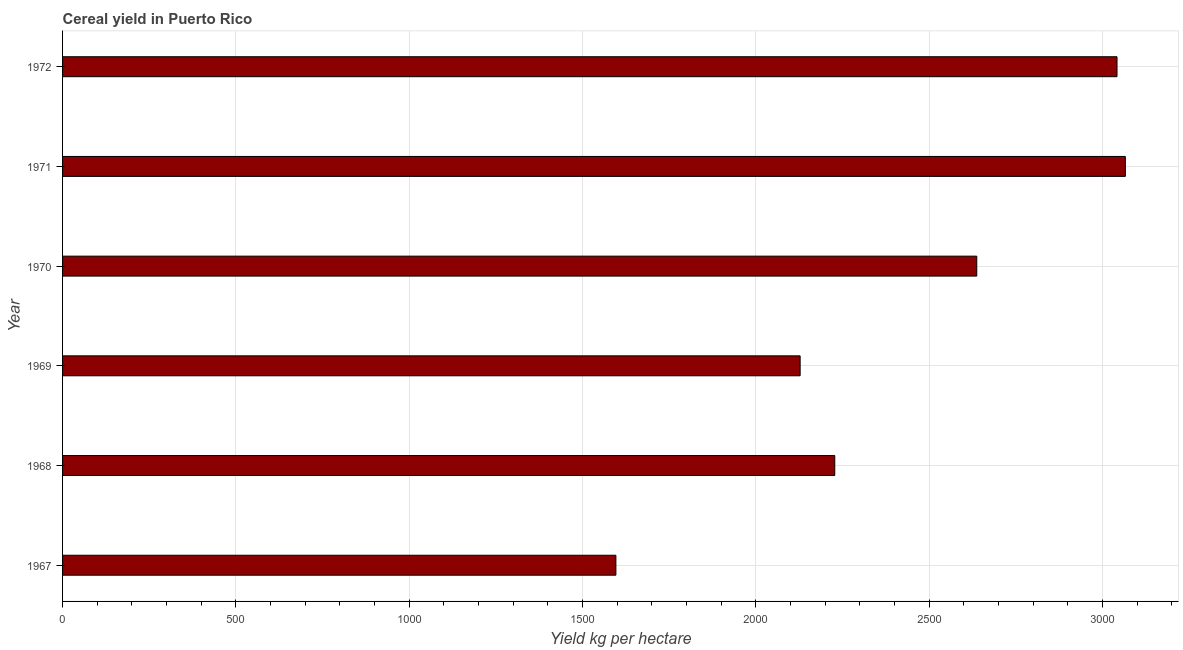What is the title of the graph?
Provide a succinct answer. Cereal yield in Puerto Rico. What is the label or title of the X-axis?
Make the answer very short. Yield kg per hectare. What is the cereal yield in 1968?
Provide a short and direct response. 2227.94. Across all years, what is the maximum cereal yield?
Your response must be concise. 3066.31. Across all years, what is the minimum cereal yield?
Provide a succinct answer. 1596.42. In which year was the cereal yield maximum?
Provide a short and direct response. 1971. In which year was the cereal yield minimum?
Offer a very short reply. 1967. What is the sum of the cereal yield?
Provide a short and direct response. 1.47e+04. What is the difference between the cereal yield in 1970 and 1971?
Offer a terse response. -428.7. What is the average cereal yield per year?
Offer a very short reply. 2449.76. What is the median cereal yield?
Offer a very short reply. 2432.78. In how many years, is the cereal yield greater than 500 kg per hectare?
Keep it short and to the point. 6. What is the ratio of the cereal yield in 1967 to that in 1972?
Ensure brevity in your answer.  0.53. Is the difference between the cereal yield in 1968 and 1969 greater than the difference between any two years?
Offer a terse response. No. What is the difference between the highest and the second highest cereal yield?
Provide a short and direct response. 24.06. What is the difference between the highest and the lowest cereal yield?
Make the answer very short. 1469.89. In how many years, is the cereal yield greater than the average cereal yield taken over all years?
Offer a very short reply. 3. How many bars are there?
Your answer should be very brief. 6. Are all the bars in the graph horizontal?
Provide a short and direct response. Yes. What is the difference between two consecutive major ticks on the X-axis?
Your answer should be very brief. 500. What is the Yield kg per hectare of 1967?
Your answer should be compact. 1596.42. What is the Yield kg per hectare of 1968?
Ensure brevity in your answer.  2227.94. What is the Yield kg per hectare in 1969?
Provide a short and direct response. 2128.01. What is the Yield kg per hectare in 1970?
Your answer should be compact. 2637.61. What is the Yield kg per hectare in 1971?
Offer a very short reply. 3066.31. What is the Yield kg per hectare of 1972?
Provide a short and direct response. 3042.25. What is the difference between the Yield kg per hectare in 1967 and 1968?
Your answer should be compact. -631.52. What is the difference between the Yield kg per hectare in 1967 and 1969?
Your answer should be very brief. -531.59. What is the difference between the Yield kg per hectare in 1967 and 1970?
Your answer should be very brief. -1041.19. What is the difference between the Yield kg per hectare in 1967 and 1971?
Ensure brevity in your answer.  -1469.89. What is the difference between the Yield kg per hectare in 1967 and 1972?
Make the answer very short. -1445.83. What is the difference between the Yield kg per hectare in 1968 and 1969?
Offer a terse response. 99.93. What is the difference between the Yield kg per hectare in 1968 and 1970?
Your answer should be very brief. -409.67. What is the difference between the Yield kg per hectare in 1968 and 1971?
Keep it short and to the point. -838.37. What is the difference between the Yield kg per hectare in 1968 and 1972?
Keep it short and to the point. -814.3. What is the difference between the Yield kg per hectare in 1969 and 1970?
Keep it short and to the point. -509.6. What is the difference between the Yield kg per hectare in 1969 and 1971?
Your response must be concise. -938.3. What is the difference between the Yield kg per hectare in 1969 and 1972?
Provide a short and direct response. -914.24. What is the difference between the Yield kg per hectare in 1970 and 1971?
Offer a terse response. -428.7. What is the difference between the Yield kg per hectare in 1970 and 1972?
Provide a short and direct response. -404.63. What is the difference between the Yield kg per hectare in 1971 and 1972?
Your answer should be compact. 24.06. What is the ratio of the Yield kg per hectare in 1967 to that in 1968?
Ensure brevity in your answer.  0.72. What is the ratio of the Yield kg per hectare in 1967 to that in 1969?
Provide a short and direct response. 0.75. What is the ratio of the Yield kg per hectare in 1967 to that in 1970?
Your answer should be very brief. 0.6. What is the ratio of the Yield kg per hectare in 1967 to that in 1971?
Offer a terse response. 0.52. What is the ratio of the Yield kg per hectare in 1967 to that in 1972?
Ensure brevity in your answer.  0.53. What is the ratio of the Yield kg per hectare in 1968 to that in 1969?
Your answer should be very brief. 1.05. What is the ratio of the Yield kg per hectare in 1968 to that in 1970?
Offer a terse response. 0.84. What is the ratio of the Yield kg per hectare in 1968 to that in 1971?
Offer a terse response. 0.73. What is the ratio of the Yield kg per hectare in 1968 to that in 1972?
Your response must be concise. 0.73. What is the ratio of the Yield kg per hectare in 1969 to that in 1970?
Offer a terse response. 0.81. What is the ratio of the Yield kg per hectare in 1969 to that in 1971?
Your answer should be compact. 0.69. What is the ratio of the Yield kg per hectare in 1969 to that in 1972?
Provide a succinct answer. 0.7. What is the ratio of the Yield kg per hectare in 1970 to that in 1971?
Offer a very short reply. 0.86. What is the ratio of the Yield kg per hectare in 1970 to that in 1972?
Make the answer very short. 0.87. What is the ratio of the Yield kg per hectare in 1971 to that in 1972?
Keep it short and to the point. 1.01. 